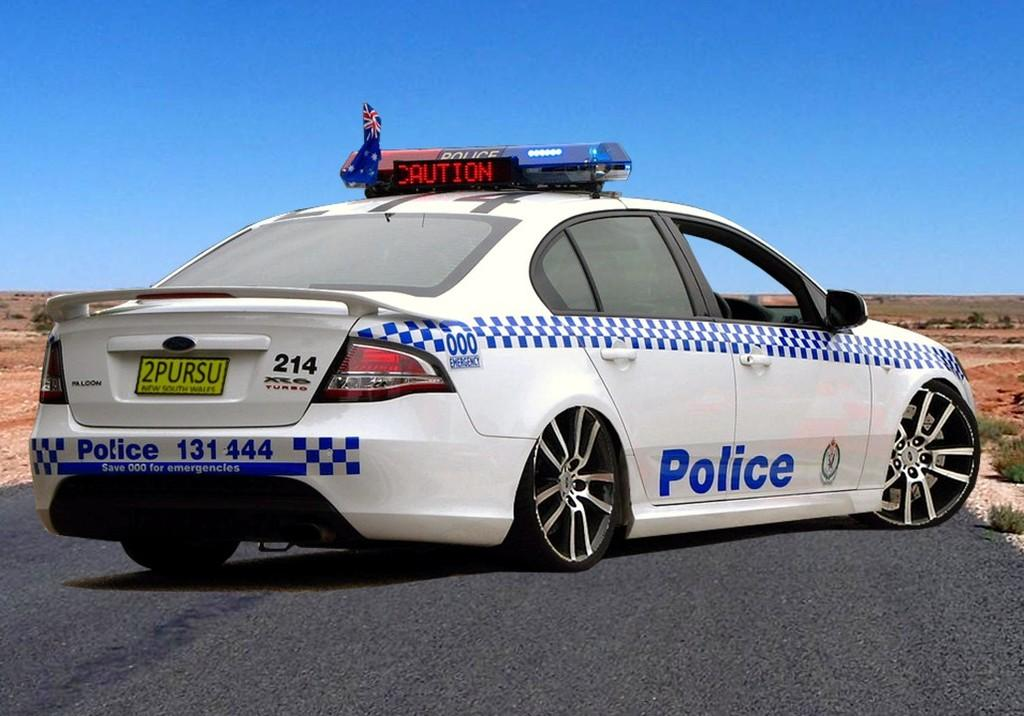What type of vehicle is in the image? There is a police vehicle in the image. What colors are used for the police vehicle? The police vehicle is white and blue in color. Where is the police vehicle located? The police vehicle is on the road. What can be seen on either side of the police vehicle? There are plants on either side of the police vehicle. Can you tell me how many babies are sitting inside the police vehicle? There is no baby present inside the police vehicle in the image. Is there a judge standing next to the police vehicle? There is no judge present next to the police vehicle in the image. 